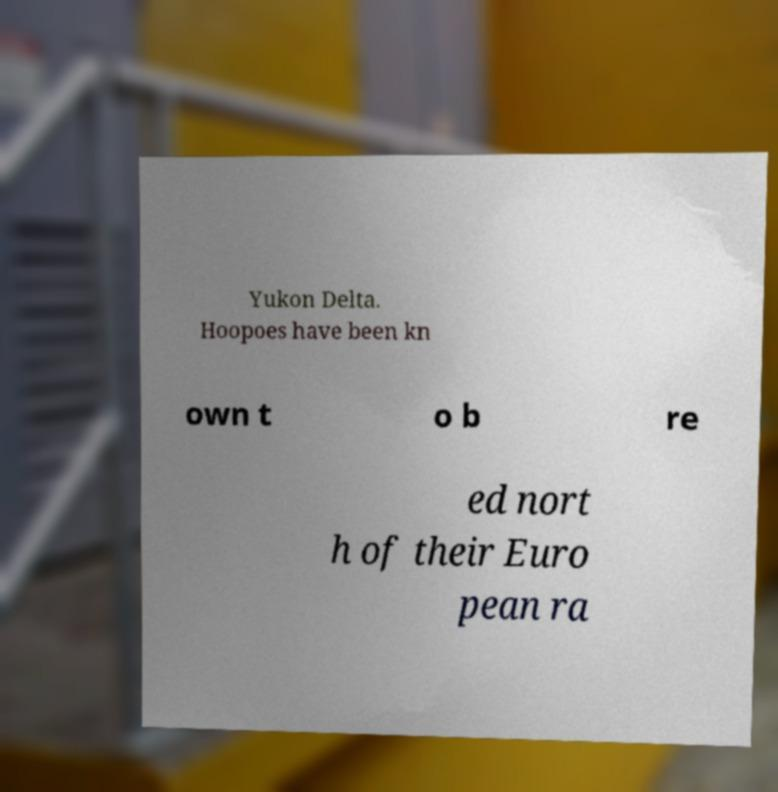Could you extract and type out the text from this image? Yukon Delta. Hoopoes have been kn own t o b re ed nort h of their Euro pean ra 